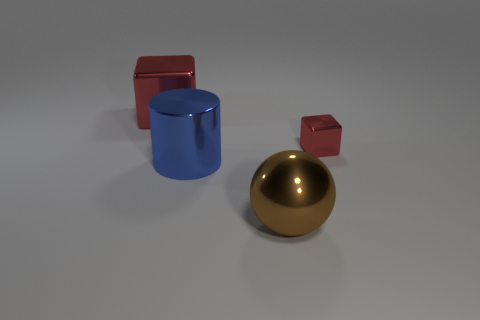What can you tell about the lighting and shadows in the image? The objects are casting soft-edged shadows to the right, which suggests a diffuse light source coming from the left. The lighting seems even and soft, without harsh highlights, indicating it may be an overcast or studio lighting setup. 